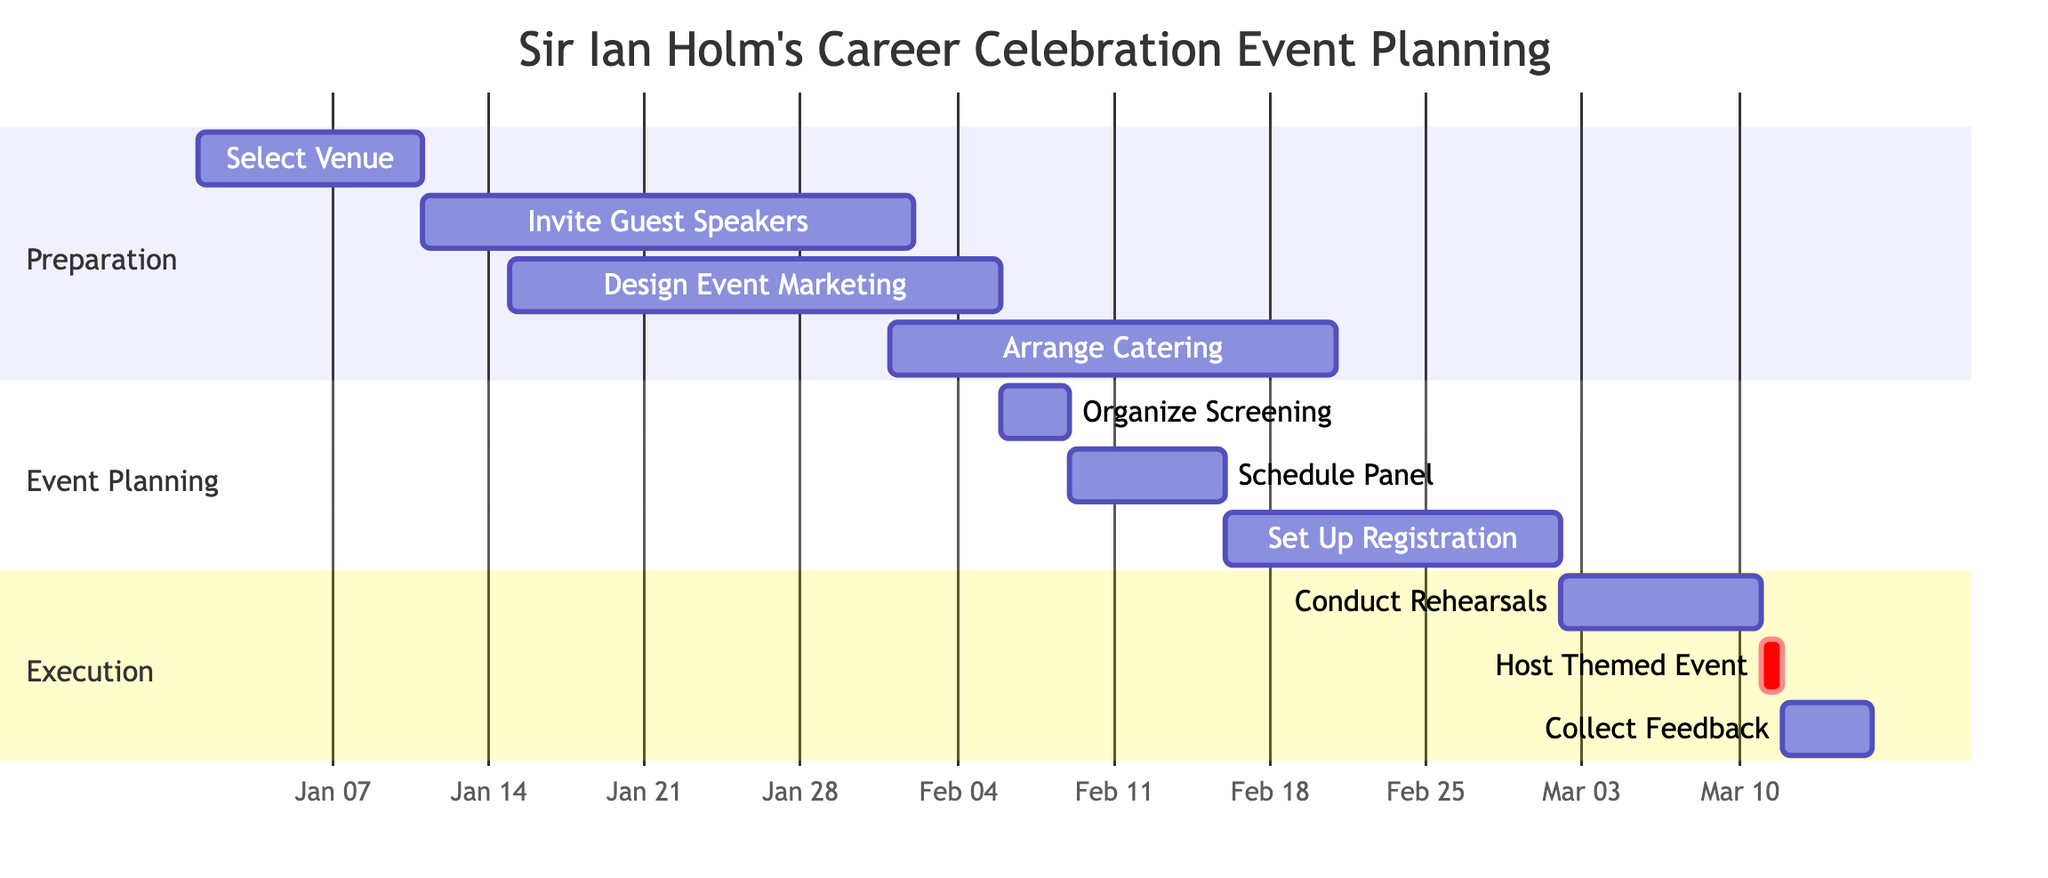What is the duration of the "Select Venue" task? The "Select Venue" task starts on January 1, 2024, and ends on January 10, 2024. This gives it a duration of 10 days.
Answer: 10 days How many tasks are scheduled in the "Event Planning" section? The "Event Planning" section contains three tasks: "Organize Screening," "Schedule Panel," and "Set Up Registration."
Answer: 3 tasks Which task is scheduled immediately before "Host Themed Event"? "Conduct Event Rehearsals" is scheduled from March 2 to March 10, 2024, which immediately precedes the "Host Themed Event" on March 11, 2024.
Answer: Conduct Event Rehearsals What is the start date of "Design Event Marketing Materials"? The "Design Event Marketing Materials" task starts on January 15, 2024, as indicated in the diagram.
Answer: January 15, 2024 What is the total duration of tasks in the "Execution" section? The "Execution" section includes "Conduct Rehearsals" for 9 days, "Host Themed Event" for 1 day, and "Collect Feedback" for 4 days. The total duration is 9 + 1 + 4 = 14 days.
Answer: 14 days How many days is the "Invite Guest Speakers" task? The "Invite Guest Speakers" task starts on January 11, 2024, and ends on February 1, 2024, which totals 22 days.
Answer: 22 days What activity occurs from February 9 to February 15? The task scheduled during this period is the "Schedule Panel Discussion," which focuses on Sir Ian Holm's roles in "The Hobbit" and "Alien."
Answer: Schedule Panel Discussion What is the start date of the task "Collect Feedback"? The "Collect Feedback" task begins on March 12, 2024, as shown in the diagram.
Answer: March 12, 2024 What happens on the same day as "Host Themed Event"? The "Host Themed Event" occurs on March 11, 2024, where guests celebrate Sir Ian Holm's career. No other tasks are scheduled that day.
Answer: Host Themed Event 